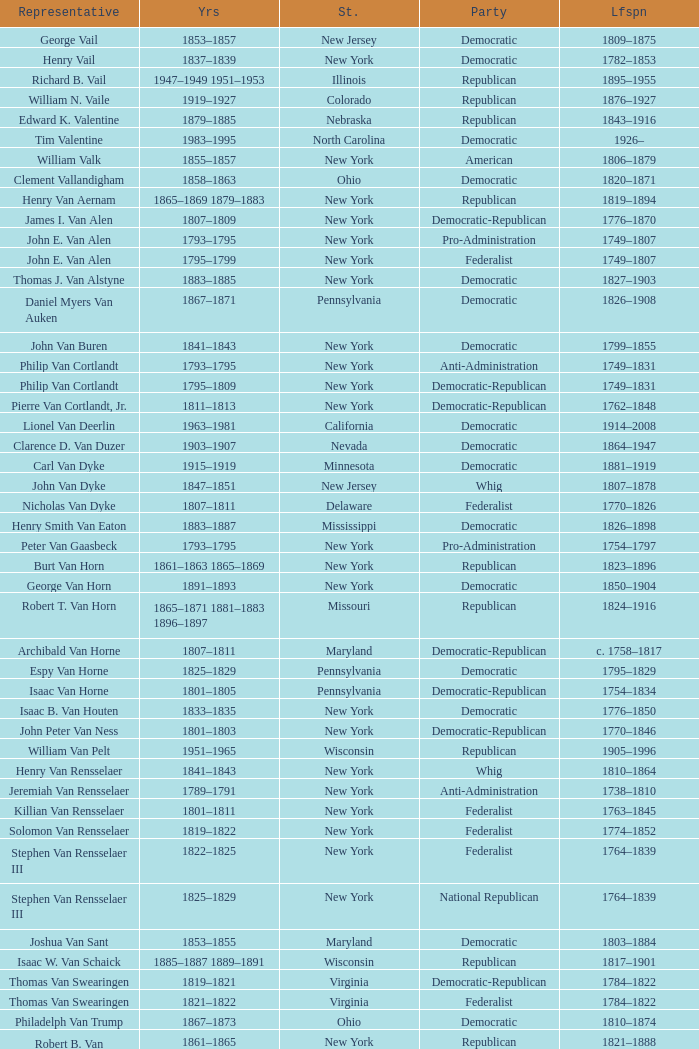What is the lifespan of Joseph Vance, a democratic-republican from Ohio? 1786–1852. 